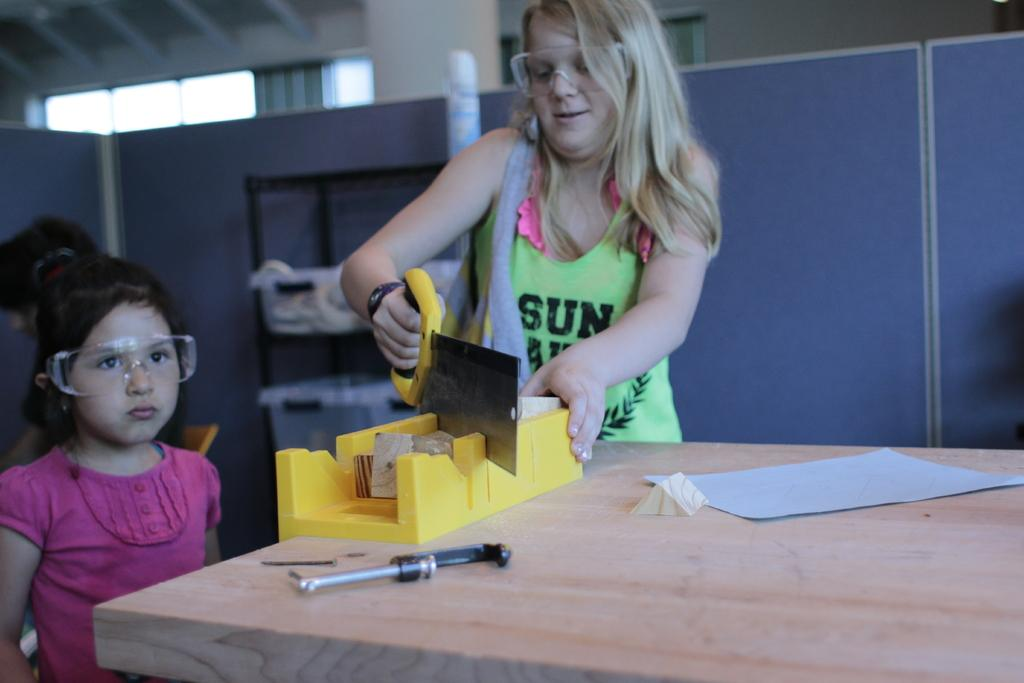How many people are in the image? There are two girls in the image. What is one of the girls holding? One of the girls is holding a tool. Where is the zoo located in the image? There is no zoo present in the image. What type of drain is visible in the image? There is no drain present in the image. 